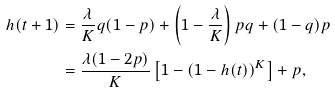Convert formula to latex. <formula><loc_0><loc_0><loc_500><loc_500>h ( t + 1 ) & = \frac { \lambda } { K } q ( 1 - p ) + \left ( 1 - \frac { \lambda } { K } \right ) p q + ( 1 - q ) p \\ & = \frac { \lambda ( 1 - 2 p ) } { K } \left [ 1 - \left ( 1 - h ( t ) \right ) ^ { K } \right ] + p , \\</formula> 